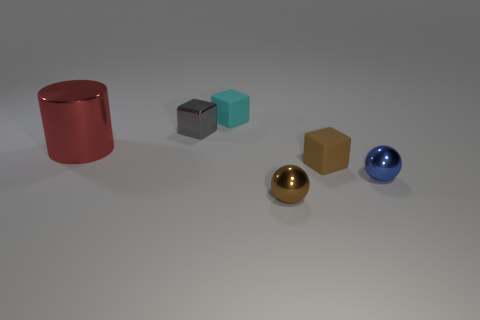What shape is the small shiny thing that is in front of the thing that is right of the brown matte cube?
Offer a very short reply. Sphere. There is a red metal cylinder behind the tiny cube that is on the right side of the tiny rubber block that is behind the big metallic thing; what size is it?
Offer a terse response. Large. What is the color of the other small matte object that is the same shape as the small cyan matte thing?
Ensure brevity in your answer.  Brown. Is the brown metallic object the same size as the red object?
Give a very brief answer. No. There is a ball to the right of the brown block; what material is it?
Keep it short and to the point. Metal. How many other things are the same shape as the small cyan object?
Keep it short and to the point. 2. Is the shape of the cyan rubber object the same as the large metallic object?
Provide a short and direct response. No. There is a red object; are there any cylinders on the left side of it?
Provide a short and direct response. No. How many objects are either small green matte objects or small brown things?
Ensure brevity in your answer.  2. How many other things are there of the same size as the red metal cylinder?
Your answer should be compact. 0. 